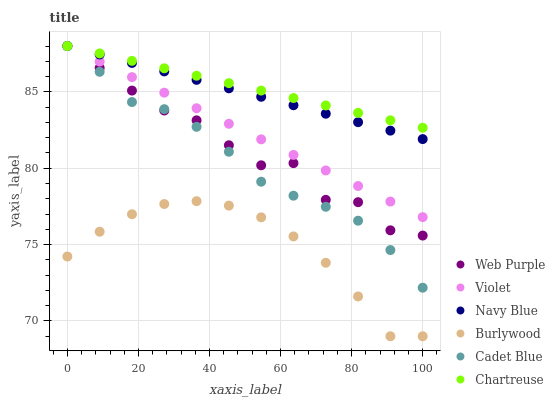Does Burlywood have the minimum area under the curve?
Answer yes or no. Yes. Does Chartreuse have the maximum area under the curve?
Answer yes or no. Yes. Does Navy Blue have the minimum area under the curve?
Answer yes or no. No. Does Navy Blue have the maximum area under the curve?
Answer yes or no. No. Is Chartreuse the smoothest?
Answer yes or no. Yes. Is Web Purple the roughest?
Answer yes or no. Yes. Is Burlywood the smoothest?
Answer yes or no. No. Is Burlywood the roughest?
Answer yes or no. No. Does Burlywood have the lowest value?
Answer yes or no. Yes. Does Navy Blue have the lowest value?
Answer yes or no. No. Does Violet have the highest value?
Answer yes or no. Yes. Does Burlywood have the highest value?
Answer yes or no. No. Is Burlywood less than Violet?
Answer yes or no. Yes. Is Chartreuse greater than Burlywood?
Answer yes or no. Yes. Does Violet intersect Navy Blue?
Answer yes or no. Yes. Is Violet less than Navy Blue?
Answer yes or no. No. Is Violet greater than Navy Blue?
Answer yes or no. No. Does Burlywood intersect Violet?
Answer yes or no. No. 